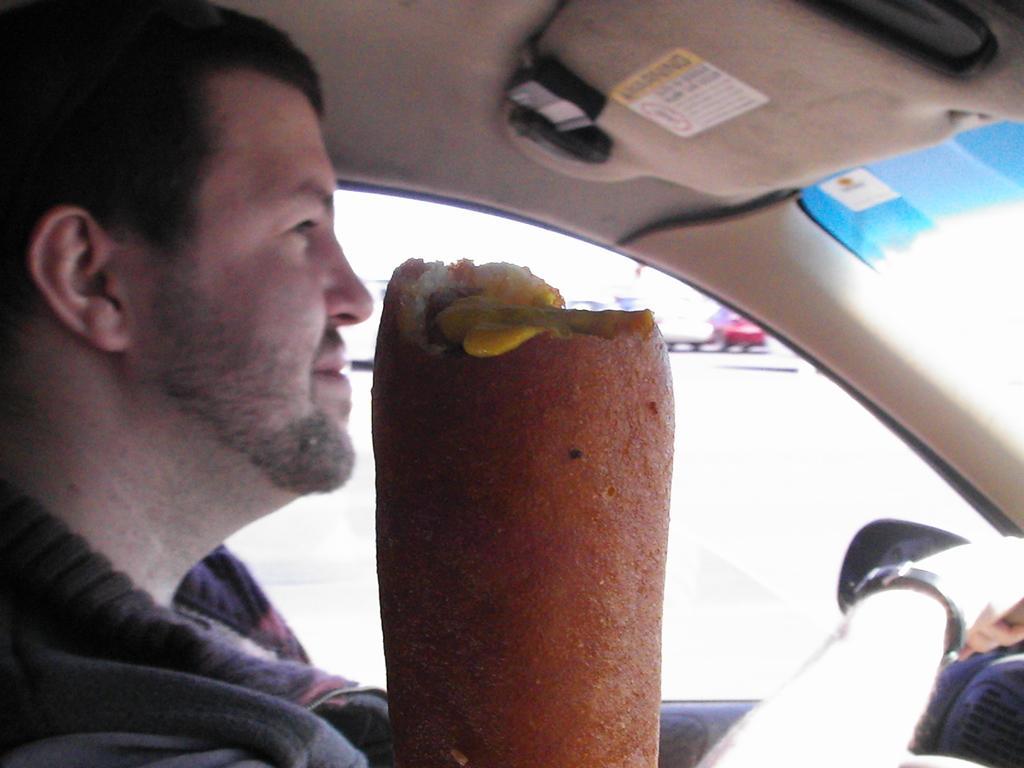Can you describe this image briefly? In this image I can see a person sitting in the car, in front I can see food which is in brown color. Background I can see few other vehicles. 